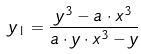<formula> <loc_0><loc_0><loc_500><loc_500>y _ { 1 } = \frac { y ^ { 3 } - a \cdot x ^ { 3 } } { a \cdot y \cdot x ^ { 3 } - y }</formula> 